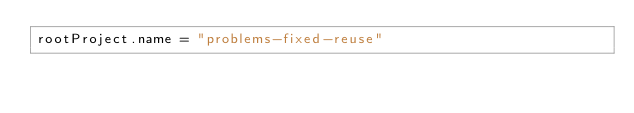Convert code to text. <code><loc_0><loc_0><loc_500><loc_500><_Kotlin_>rootProject.name = "problems-fixed-reuse"
</code> 